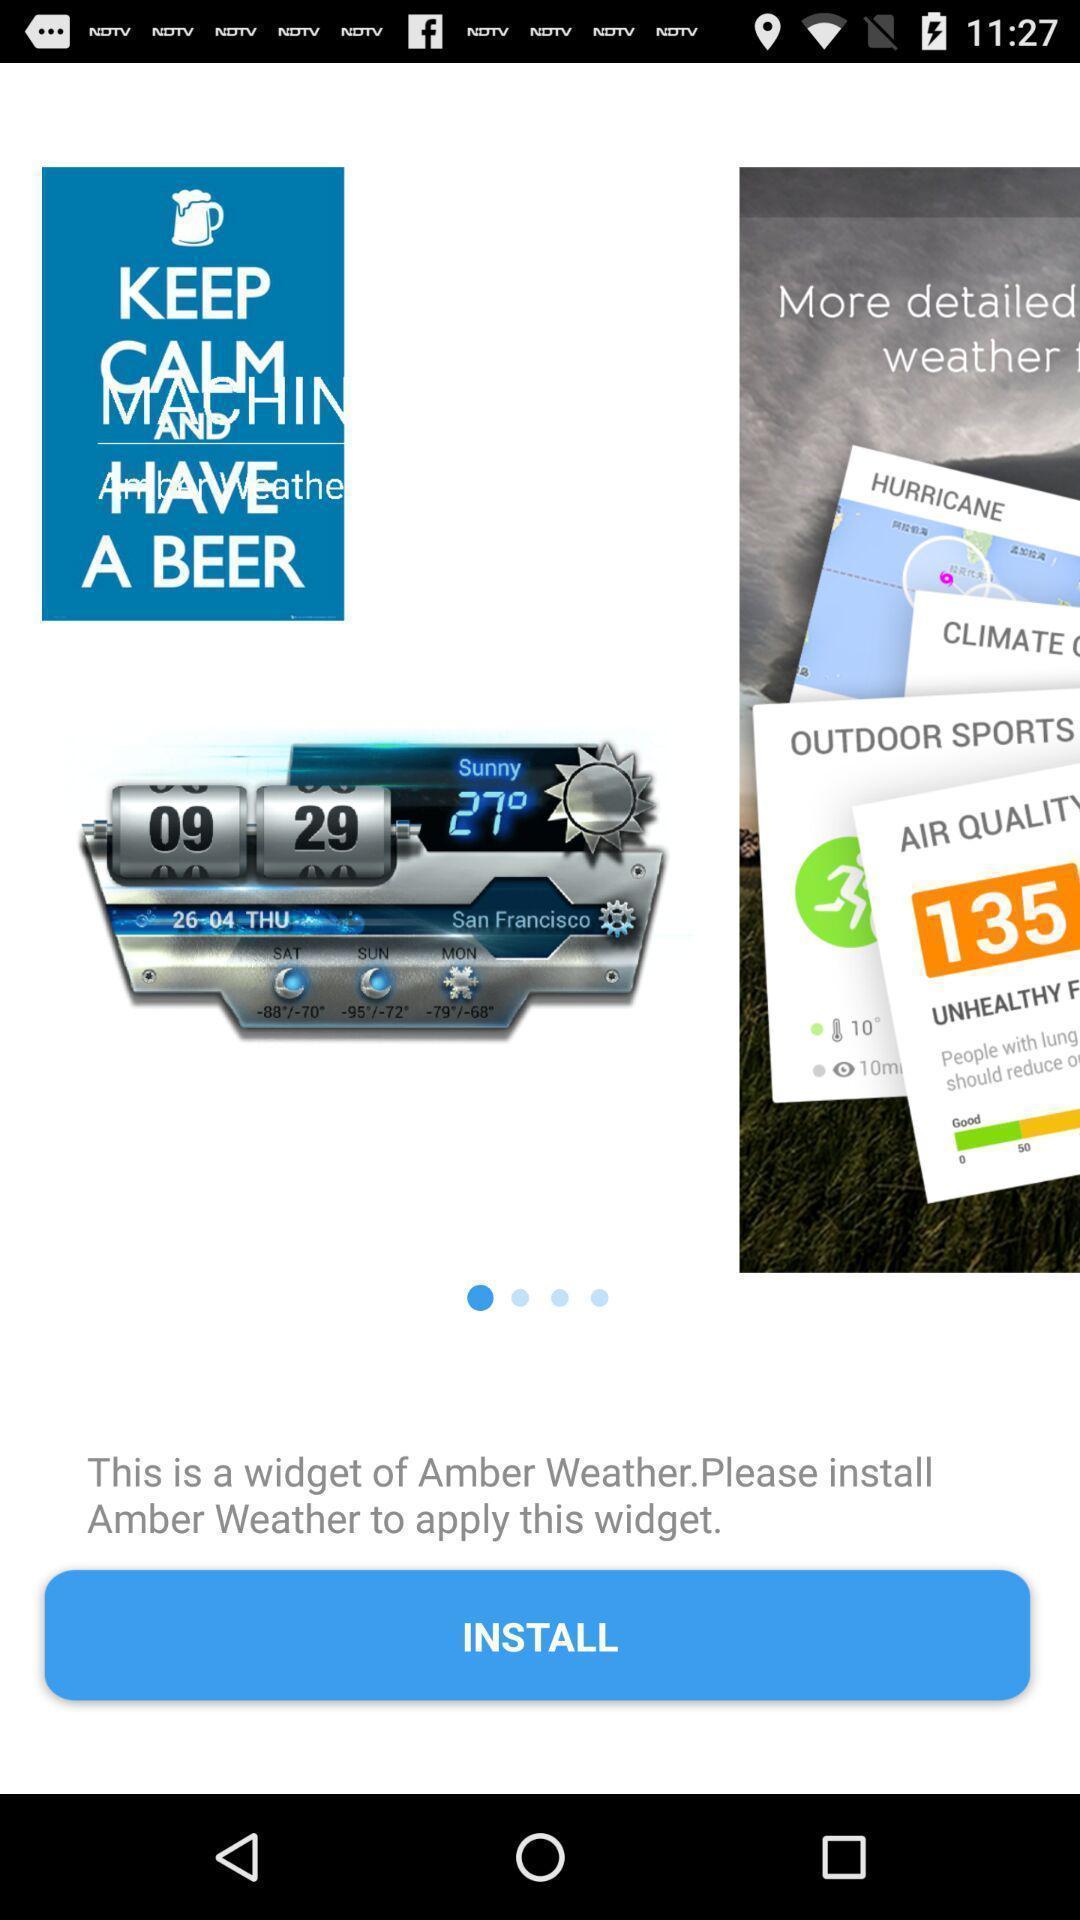Give me a summary of this screen capture. Screen displaying information about the weather application. 